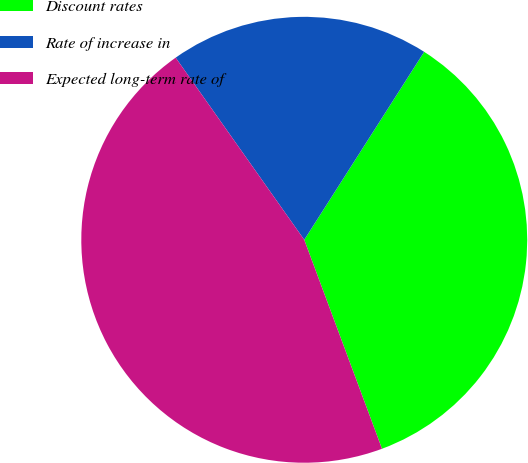Convert chart to OTSL. <chart><loc_0><loc_0><loc_500><loc_500><pie_chart><fcel>Discount rates<fcel>Rate of increase in<fcel>Expected long-term rate of<nl><fcel>35.29%<fcel>18.82%<fcel>45.88%<nl></chart> 